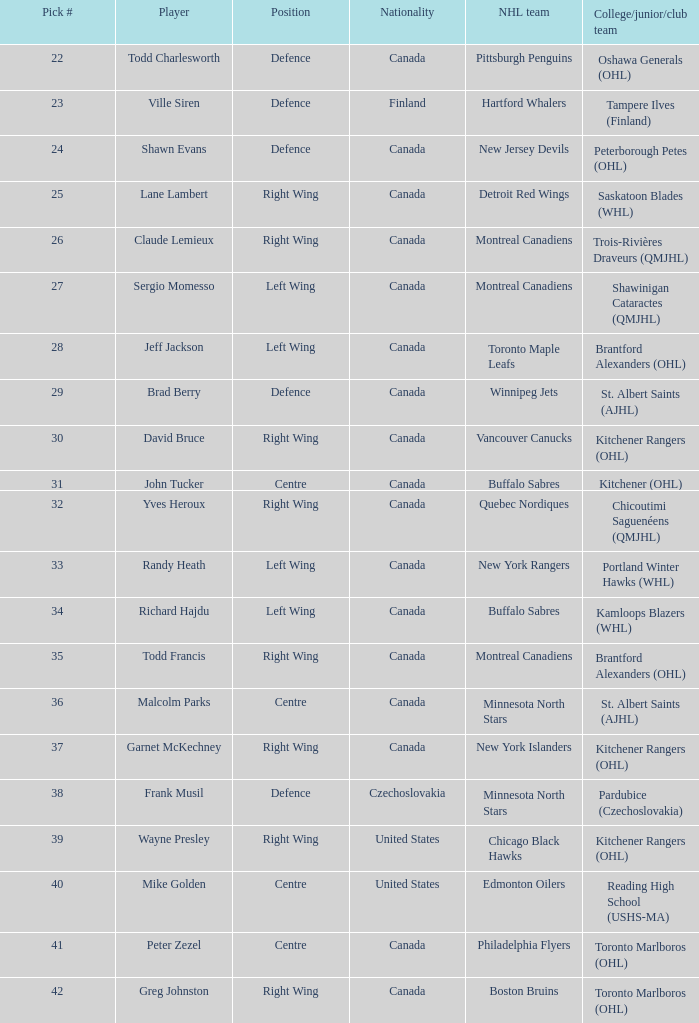What is the position for the nhl team toronto maple leafs? Left Wing. 